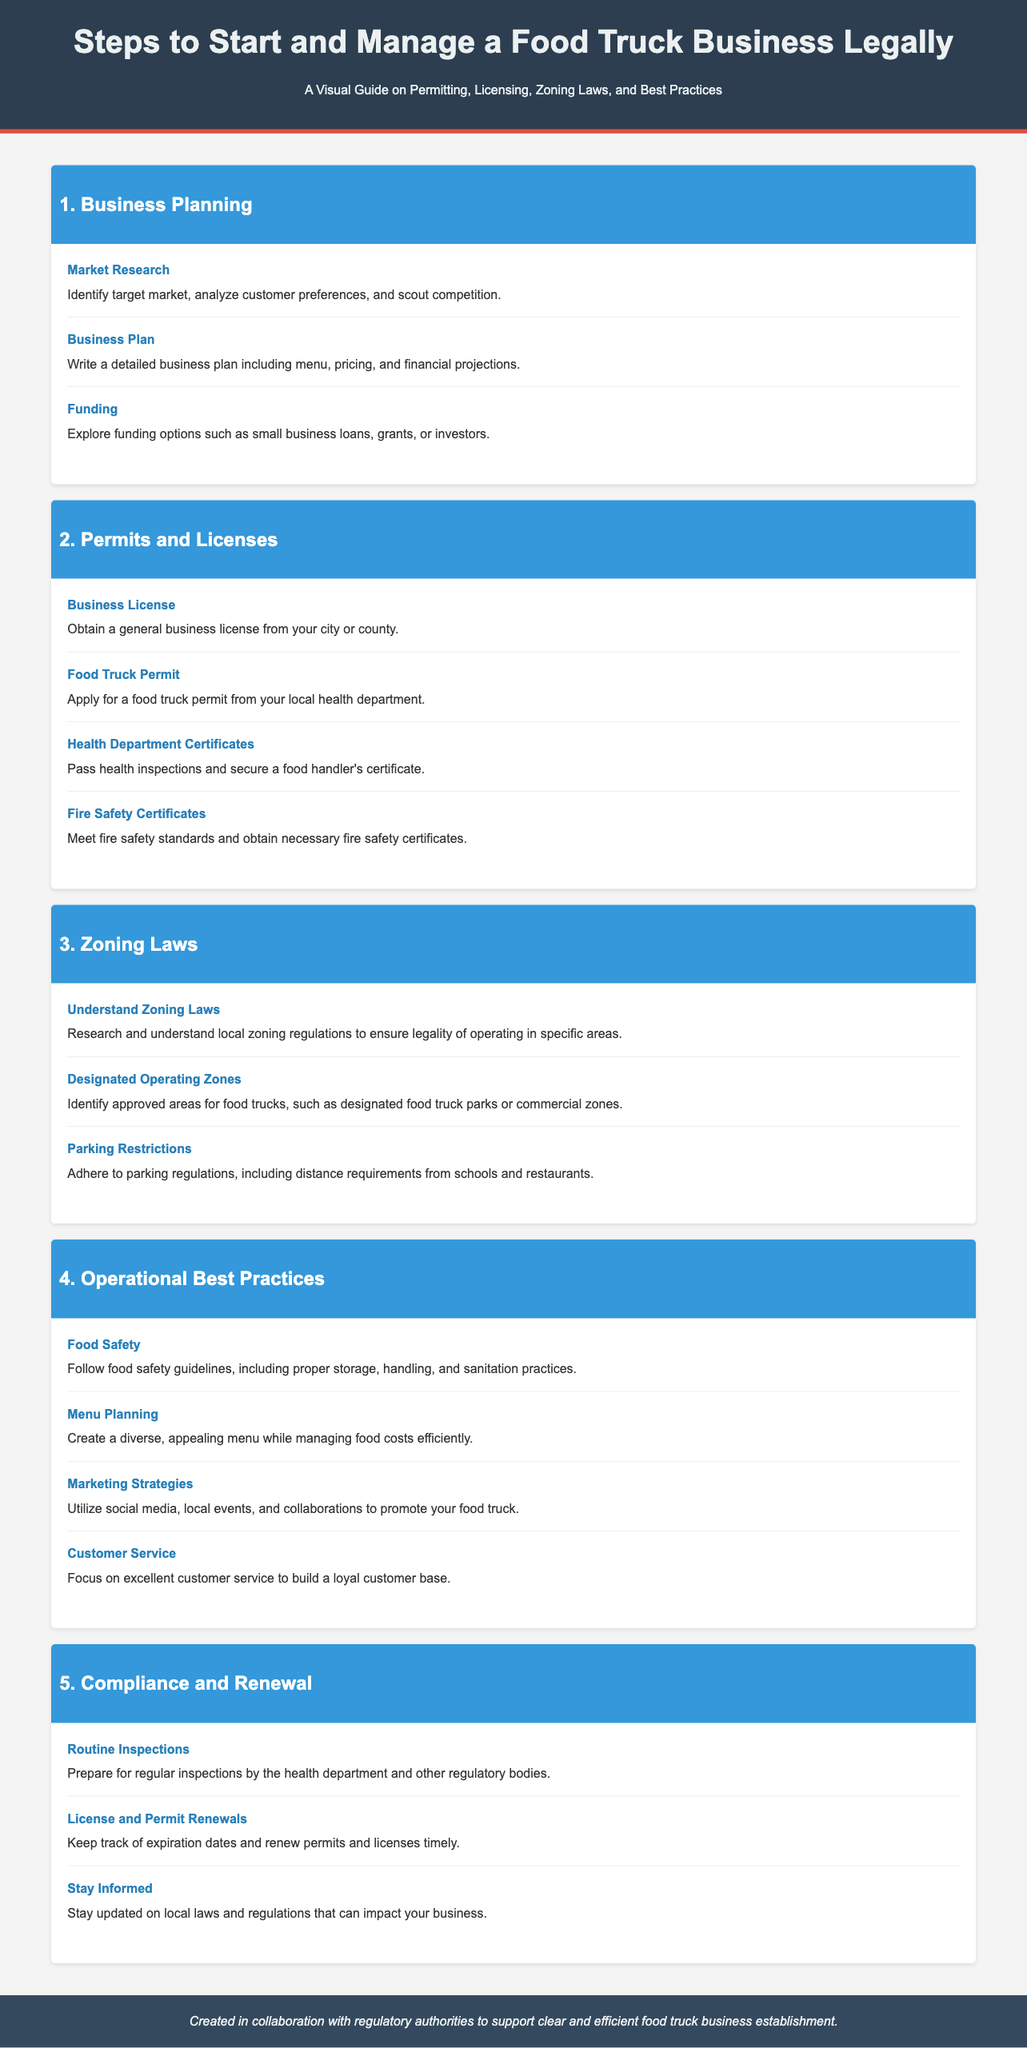what should you identify in market research? The document states that market research should identify the target market, analyze customer preferences, and scout competition.
Answer: target market which type of certificate is required from the health department? The document indicates that a food handler's certificate is necessary after passing health inspections.
Answer: food handler's certificate what is needed to start a food truck business in the city or county? The document mentions that a general business license must be obtained from the city or county to start.
Answer: general business license what must you adhere to regarding parking restrictions? The document outlines that you must adhere to parking regulations, including distance requirements from schools and restaurants.
Answer: parking regulations what should you focus on to build a loyal customer base? The document highlights that focusing on excellent customer service is essential to build a loyal customer base.
Answer: excellent customer service how often should you prepare for inspections? The document states that you should prepare for routine inspections by the health department and other regulatory bodies.
Answer: routine inspections which funding option is mentioned for food truck businesses? The document suggests exploring small business loans, grants, or investors as funding options.
Answer: small business loans what must be tracked and renewed in compliance? The document states that you must keep track of expiration dates and renew permits and licenses timely.
Answer: permits and licenses what type of laws should be researched for food truck operations? The document indicates that local zoning regulations need to be researched for food truck operations.
Answer: zoning regulations 